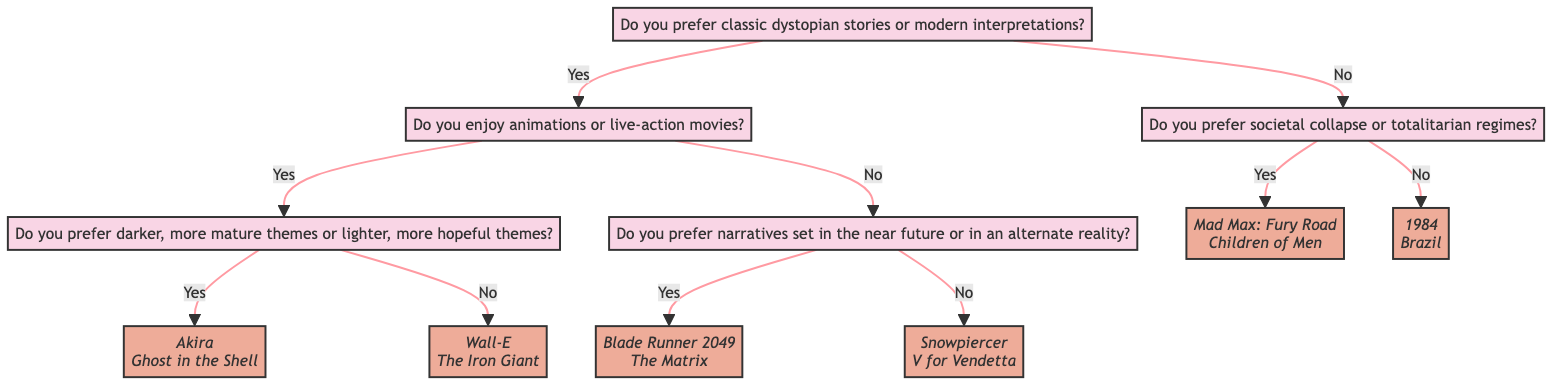What is the first question in the diagram? The first question is at the 'Start' node, which asks whether the viewer prefers classic dystopian stories or modern interpretations.
Answer: Do you prefer classic dystopian stories or modern interpretations? How many suggestions are under "Societal Collapse"? The "Societal Collapse" node leads to two movie suggestions listed below it. The number of suggestions can be counted directly from that node.
Answer: 2 What type of movies does "Darker Themes" suggest? The node labeled "Darker Themes" provides movie suggestions, which are Akira and Ghost in the Shell—both of which are animated films with mature themes.
Answer: Akira, Ghost in the Shell If someone prefers animations and lighter themes, which movie suggestions would they receive? Starting from the "Start" node, the viewer would go to the "Modern" node for preferring modern stories, then to the "Animations" node for favoring animations, and finally to the "Hopeful Themes" node, which lists its movies.
Answer: Wall-E, The Iron Giant If a viewer chooses "Totalitarian Regimes," what are the suggestions? From the "Totalitarian Regimes" node, there are two movie titles listed as suggestions. By looking directly under that node, we find the names of the suggested films.
Answer: 1984, Brazil How does one reach the "Near Future" suggestion? Beginning at the "Start" node, if the viewer chooses "Modern" for preferring modern interpretations, then selects "Live-action," and finally states a preference for narratives set in the near future, they reach the "Near Future" node, which offers suggestions.
Answer: Blade Runner 2049, The Matrix What genre does the "Classic" path lead to if the answer is "no" for societal collapse? Following the path from the "Classic" node, if the answer given is "no," it leads to the "Totalitarian Regimes" node, from which movie suggestions can be seen.
Answer: Totalitarian Regimes How many edges are connected to the "Live-action" node? To determine the number of edges connected to the "Live-action" node, count how many paths lead to and from this node. There are two edges: one leading to "Near Future" and one to "Alternate Reality."
Answer: 2 